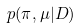<formula> <loc_0><loc_0><loc_500><loc_500>p ( \pi , \mu | D )</formula> 